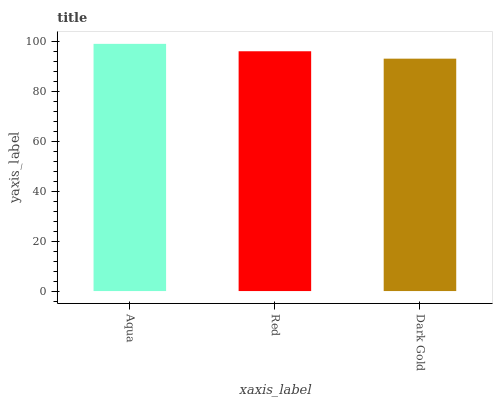Is Dark Gold the minimum?
Answer yes or no. Yes. Is Aqua the maximum?
Answer yes or no. Yes. Is Red the minimum?
Answer yes or no. No. Is Red the maximum?
Answer yes or no. No. Is Aqua greater than Red?
Answer yes or no. Yes. Is Red less than Aqua?
Answer yes or no. Yes. Is Red greater than Aqua?
Answer yes or no. No. Is Aqua less than Red?
Answer yes or no. No. Is Red the high median?
Answer yes or no. Yes. Is Red the low median?
Answer yes or no. Yes. Is Dark Gold the high median?
Answer yes or no. No. Is Dark Gold the low median?
Answer yes or no. No. 